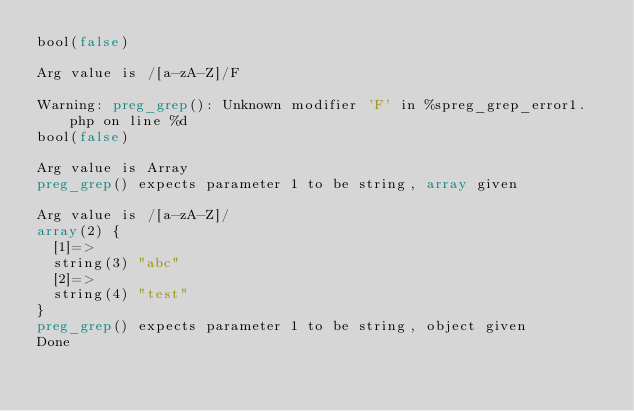Convert code to text. <code><loc_0><loc_0><loc_500><loc_500><_PHP_>bool(false)

Arg value is /[a-zA-Z]/F

Warning: preg_grep(): Unknown modifier 'F' in %spreg_grep_error1.php on line %d
bool(false)

Arg value is Array
preg_grep() expects parameter 1 to be string, array given

Arg value is /[a-zA-Z]/
array(2) {
  [1]=>
  string(3) "abc"
  [2]=>
  string(4) "test"
}
preg_grep() expects parameter 1 to be string, object given
Done
</code> 